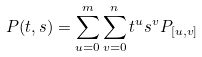Convert formula to latex. <formula><loc_0><loc_0><loc_500><loc_500>P ( t , s ) = \sum ^ { m } _ { u = 0 } \sum ^ { n } _ { v = 0 } t ^ { u } s ^ { v } P _ { [ u , v ] }</formula> 